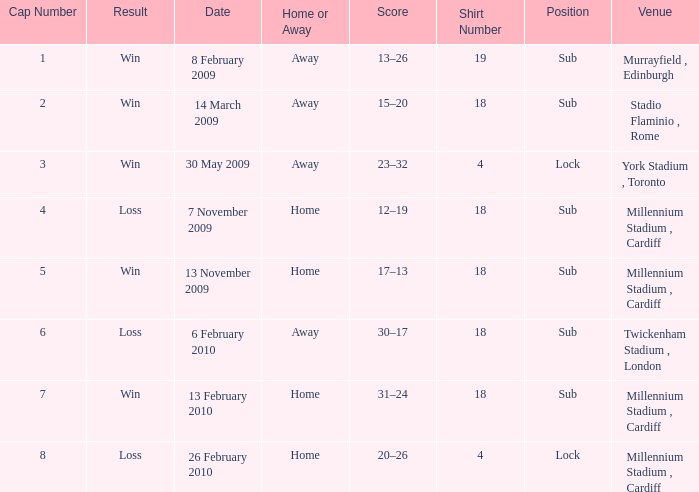Can you tell me the lowest Cap Number that has the Date of 8 february 2009, and the Shirt Number larger than 19? None. 